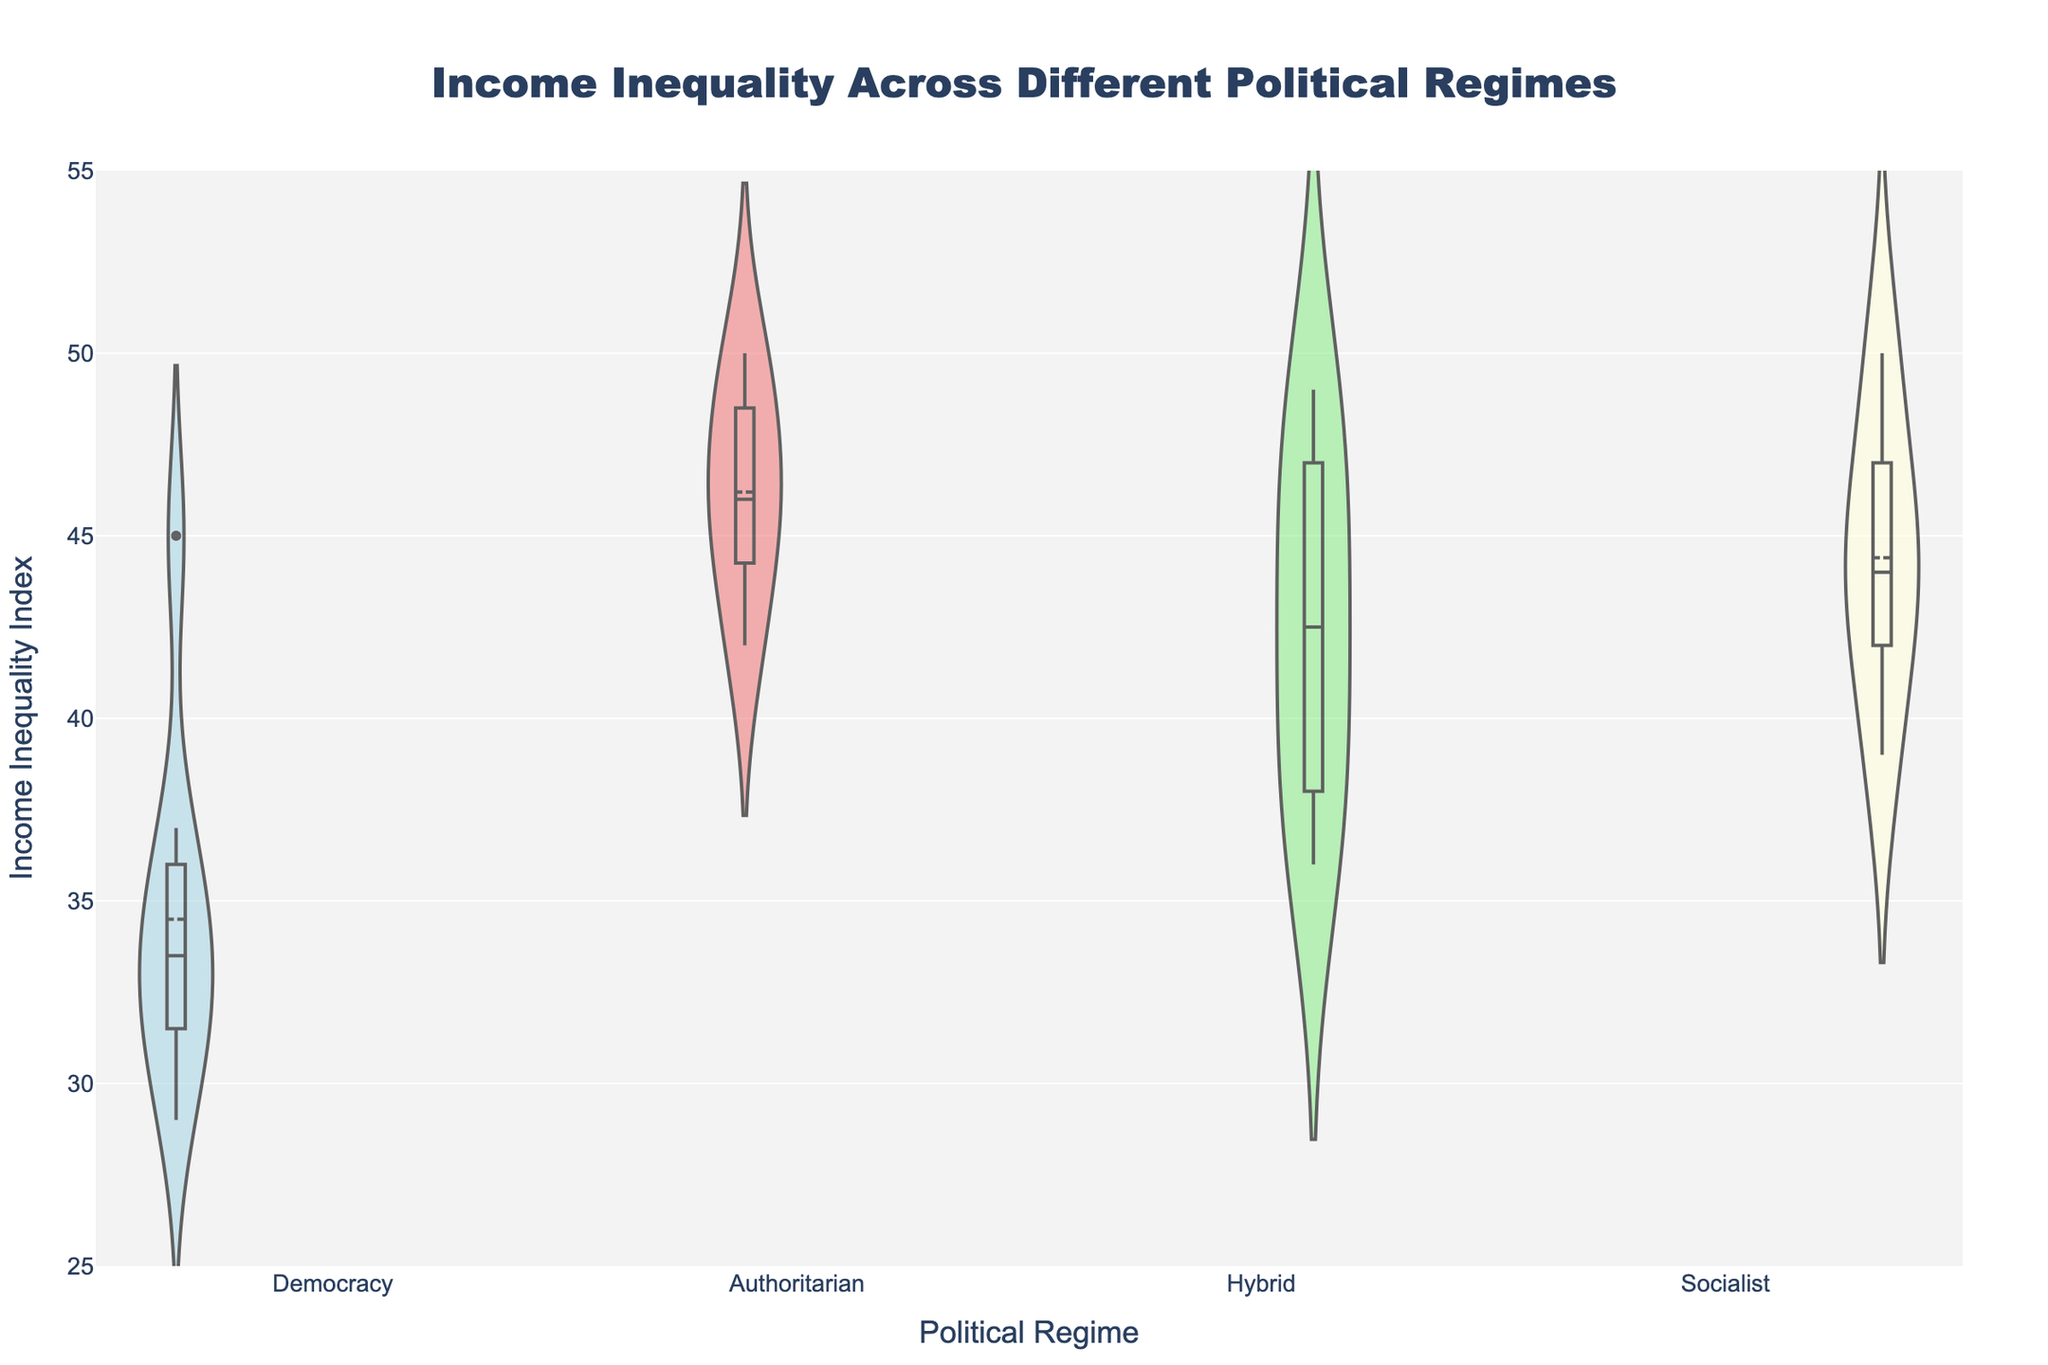What is the title of the figure? The title is typically centered at the top of the figure and provides a summary of what the figure represents. In this case, the title is "Income Inequality Across Different Political Regimes."
Answer: Income Inequality Across Different Political Regimes How many different political regimes are compared in the figure? By looking at the different groups presented on the x-axis, we can see there are four distinct political regimes being compared. These are "Democracy," "Authoritarian," "Hybrid," and "Socialist."
Answer: Four Which political regime shows the highest median income inequality index? By examining the horizontal lines within the violin plots, which represent the medians, we can observe that the "Hybrid" regime has a higher median compared to the others.
Answer: Hybrid What color represents the "Democracy" regime in the figure? By referring to the color legend in the description, "Democracy" is represented by a light blue color in the violin plot.
Answer: Light blue Which political regime has the smallest range of income inequality index? By comparing the vertical span of the violin plots, the "Democracy" regime has the smallest range, indicated by a more compressed distribution of data points.
Answer: Democracy What is the mean income inequality index for the "Authoritarian" regime? By looking at the mean lines within the "Authoritarian" violin plot, which are marked by black lines, the mean is approximately at the index of around 46.
Answer: Around 46 Compare the maximum income inequality index between "Democracy" and "Hybrid" regimes. By observing the upper edges of the violin plots, "Hybrid" has a higher maximum value at around 49, whereas "Democracy" peaks at around 37.
Answer: Hybrid is higher Which regime has more variation in income inequality, "Socialist" or "Democracy"? By comparing the width and spread of the violin plots, the "Socialist" regime displays a larger spread and thus more variation in income inequality indices than "Democracy."
Answer: Socialist What is the interquartile range (IQR) for the "Hybrid" regime? To find the IQR, locate the values at the 25th and 75th percentiles within the box plot overlaid on the "Hybrid" violin plot. The IQR is the difference between these values. For "Hybrid," the 25th percentile is around 38 and the 75th percentile is around 47, so the IQR is 47 - 38 = 9.
Answer: 9 